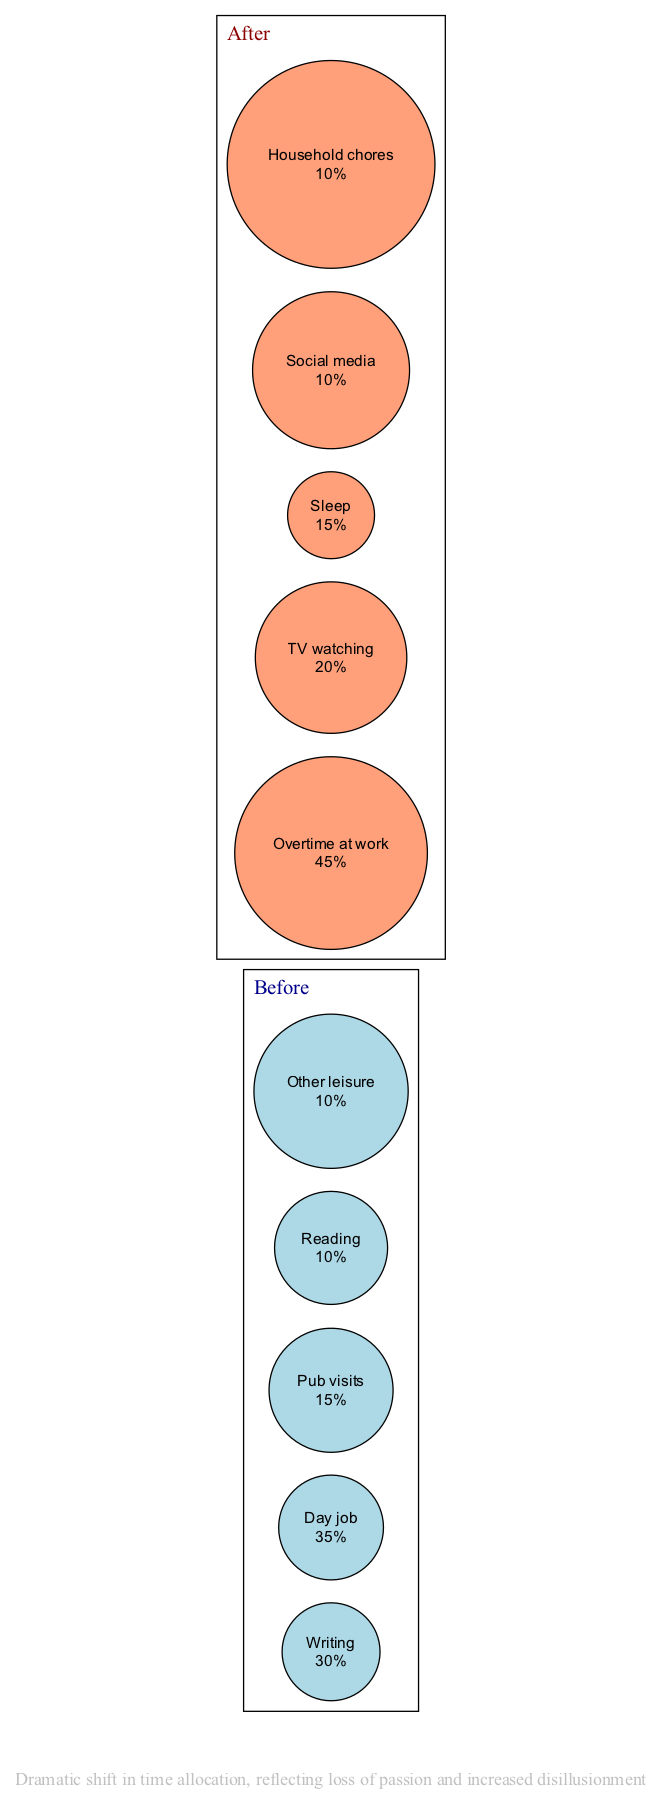What percentage of time was spent on writing before giving up on dreams? The diagram indicates that 30% of the time was allocated to writing in the "Before" segment.
Answer: 30% What activity took up the largest portion of time after giving up on writing? In the "After" segment of the diagram, the largest portion of time was allocated to "Overtime at work," which is shown to be 45%.
Answer: Overtime at work How much time was devoted to leisure activities before giving up? To find the total leisure time before giving up writing, we sum "Pub visits" (15%) and "Reading" (10%) and "Other leisure" (10%), which totals 35%.
Answer: 35% What was the percentage shift in time spent on writing before and after giving up? Writing accounted for 30% before and 0% after giving up; the shift is thus a decrease of 30%.
Answer: 30% Which activity had the same percentage allocation for both before and after? The activities "Social media" after giving up and "Other leisure" before are both shown as 10%.
Answer: None 